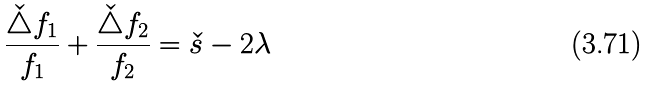<formula> <loc_0><loc_0><loc_500><loc_500>\frac { \check { \triangle } f _ { 1 } } { f _ { 1 } } + \frac { \check { \triangle } f _ { 2 } } { f _ { 2 } } = \check { s } - 2 \lambda</formula> 